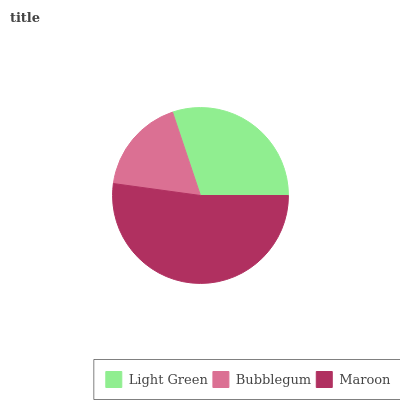Is Bubblegum the minimum?
Answer yes or no. Yes. Is Maroon the maximum?
Answer yes or no. Yes. Is Maroon the minimum?
Answer yes or no. No. Is Bubblegum the maximum?
Answer yes or no. No. Is Maroon greater than Bubblegum?
Answer yes or no. Yes. Is Bubblegum less than Maroon?
Answer yes or no. Yes. Is Bubblegum greater than Maroon?
Answer yes or no. No. Is Maroon less than Bubblegum?
Answer yes or no. No. Is Light Green the high median?
Answer yes or no. Yes. Is Light Green the low median?
Answer yes or no. Yes. Is Maroon the high median?
Answer yes or no. No. Is Bubblegum the low median?
Answer yes or no. No. 